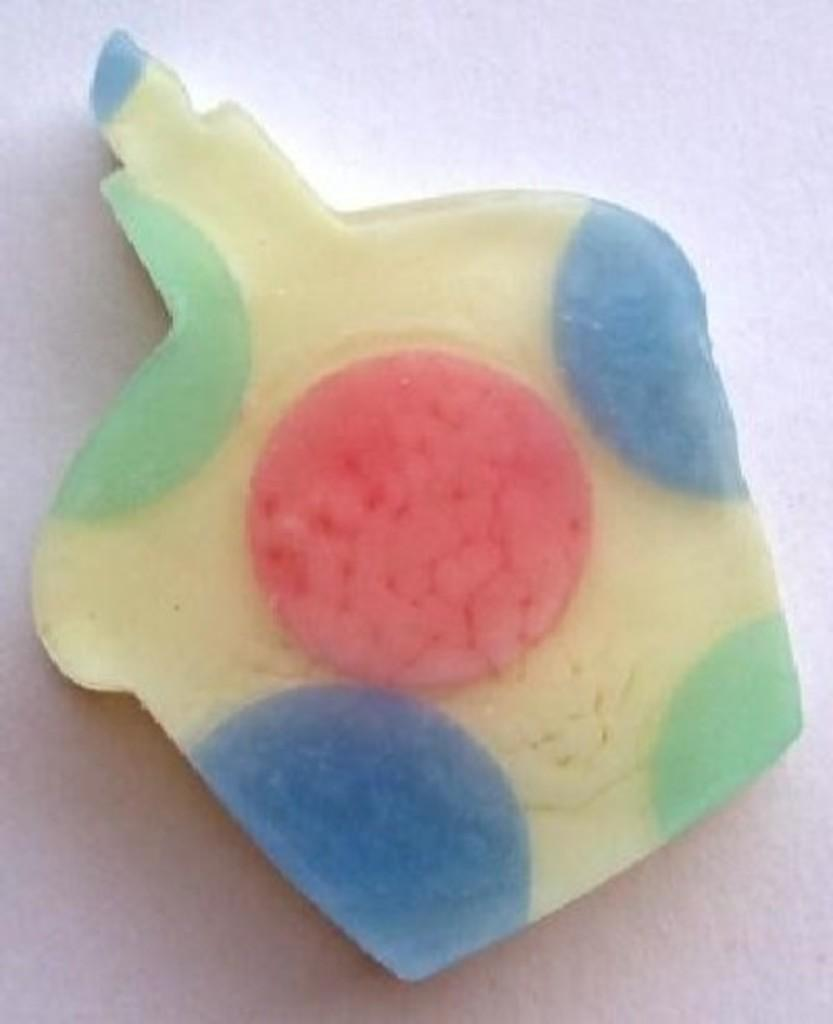What can be seen in the image? There is an object in the image. What colors are present on the object? The object has blue, green, red, and cream colors. What is the color of the surface the object is placed on? The object is on a white surface. How many balls are visible in the image? There are no balls present in the image. What type of doll is sitting on the white surface? There is no doll present in the image. 